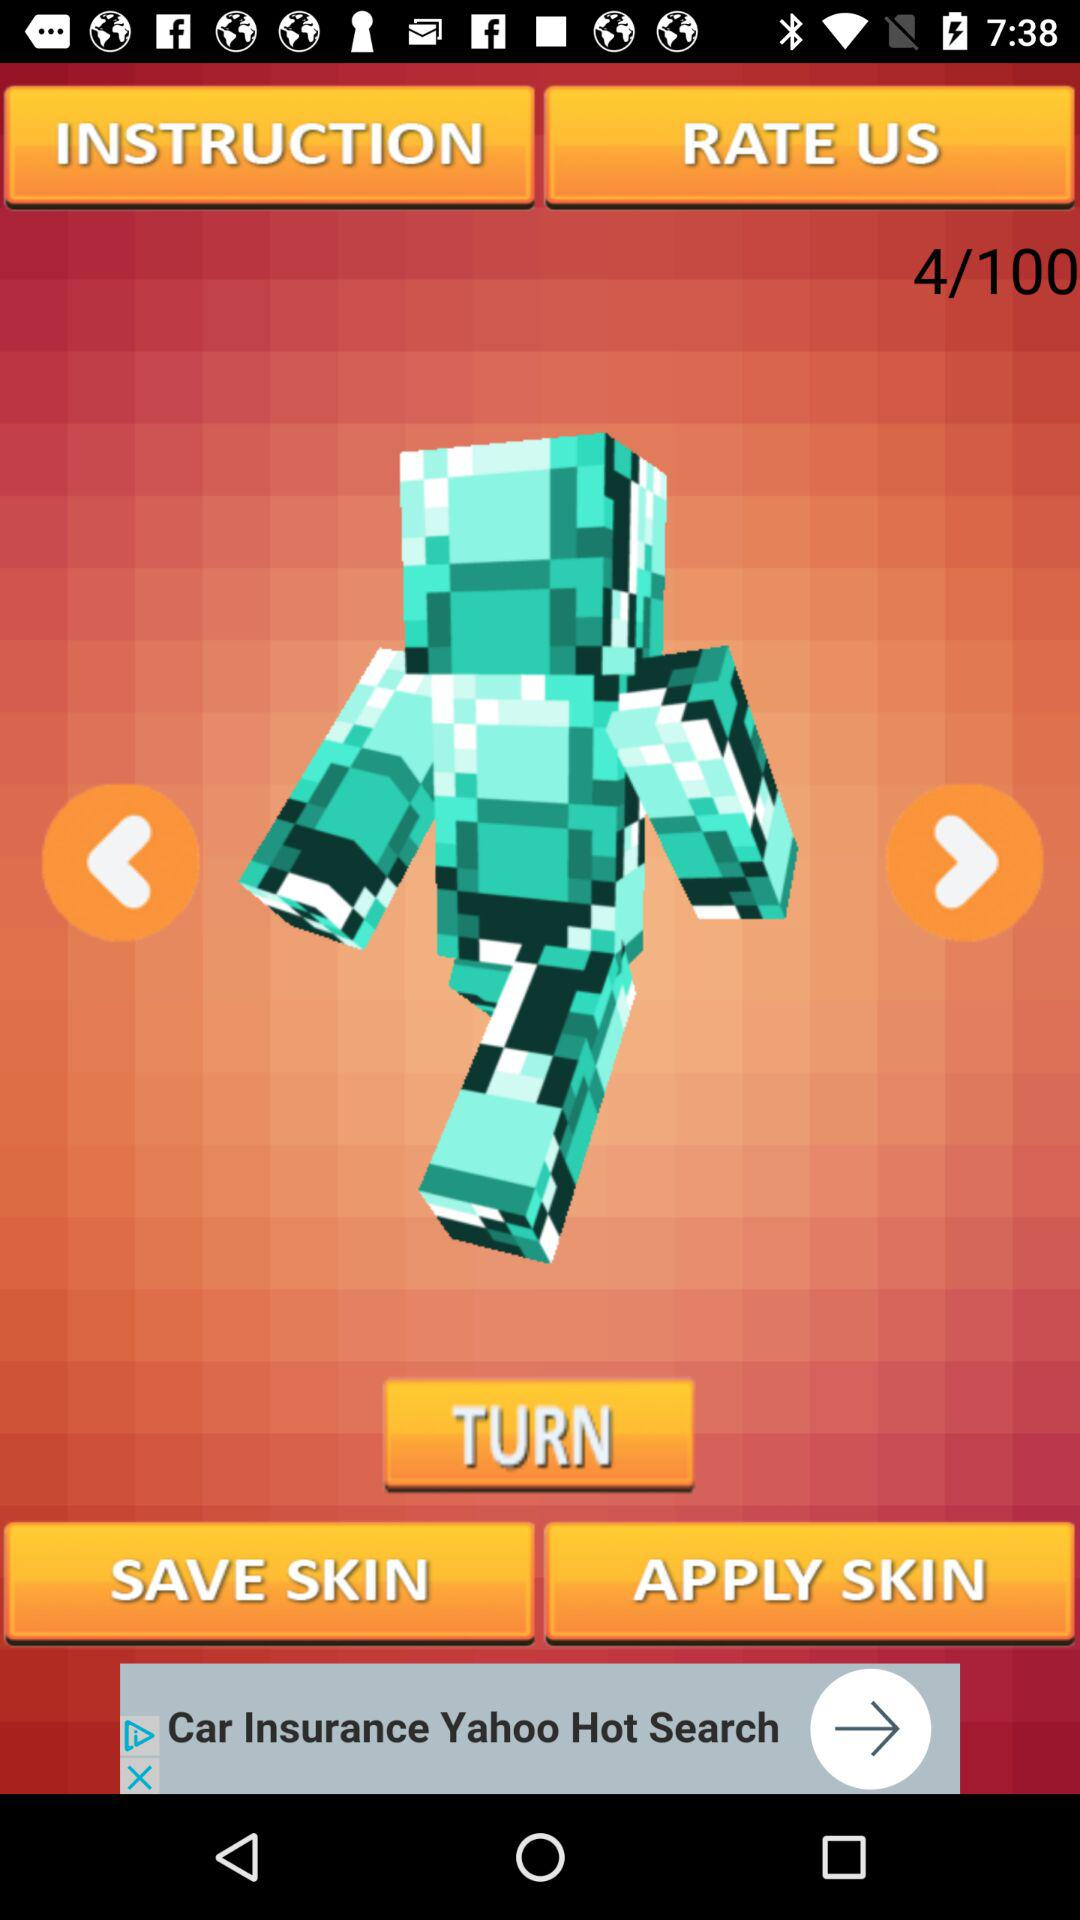How many total skins are there? There are a total of 100 skins. 